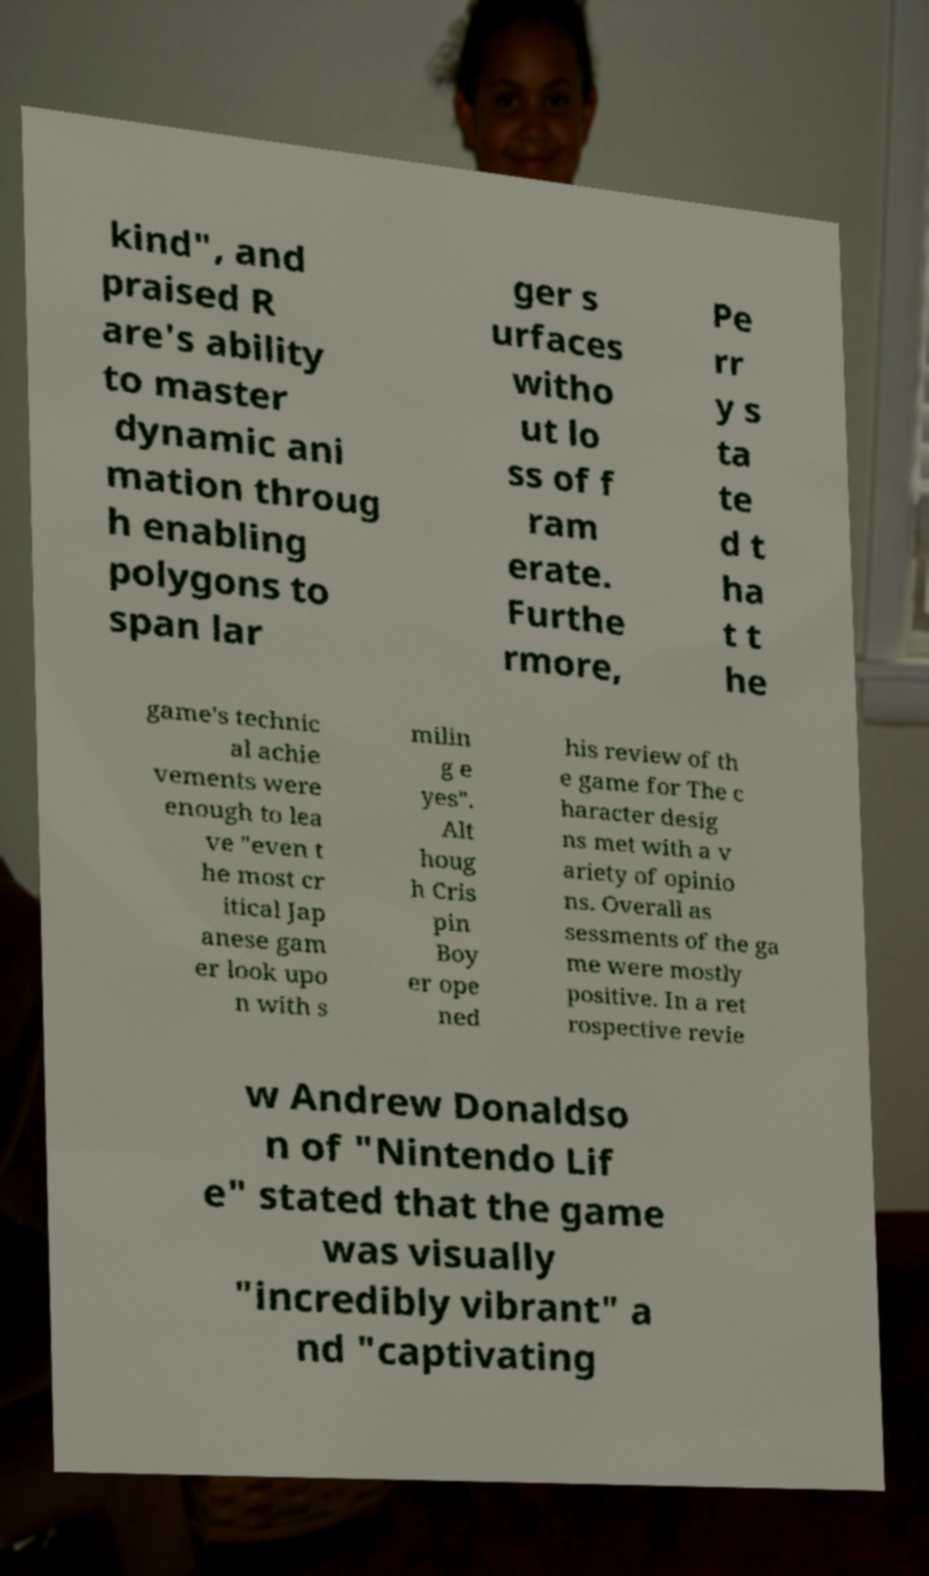For documentation purposes, I need the text within this image transcribed. Could you provide that? kind", and praised R are's ability to master dynamic ani mation throug h enabling polygons to span lar ger s urfaces witho ut lo ss of f ram erate. Furthe rmore, Pe rr y s ta te d t ha t t he game's technic al achie vements were enough to lea ve "even t he most cr itical Jap anese gam er look upo n with s milin g e yes". Alt houg h Cris pin Boy er ope ned his review of th e game for The c haracter desig ns met with a v ariety of opinio ns. Overall as sessments of the ga me were mostly positive. In a ret rospective revie w Andrew Donaldso n of "Nintendo Lif e" stated that the game was visually "incredibly vibrant" a nd "captivating 